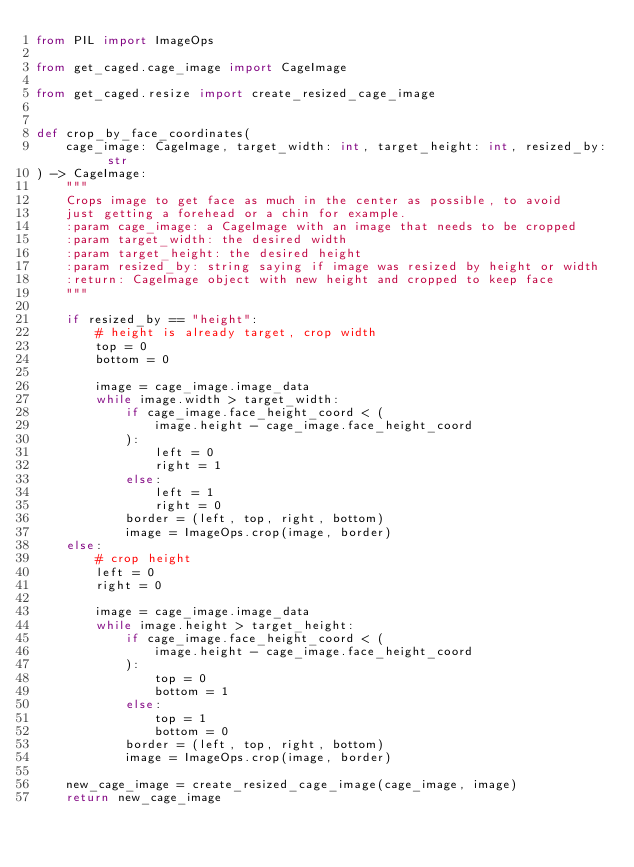<code> <loc_0><loc_0><loc_500><loc_500><_Python_>from PIL import ImageOps

from get_caged.cage_image import CageImage

from get_caged.resize import create_resized_cage_image


def crop_by_face_coordinates(
    cage_image: CageImage, target_width: int, target_height: int, resized_by: str
) -> CageImage:
    """
    Crops image to get face as much in the center as possible, to avoid
    just getting a forehead or a chin for example.
    :param cage_image: a CageImage with an image that needs to be cropped
    :param target_width: the desired width
    :param target_height: the desired height
    :param resized_by: string saying if image was resized by height or width
    :return: CageImage object with new height and cropped to keep face
    """

    if resized_by == "height":
        # height is already target, crop width
        top = 0
        bottom = 0

        image = cage_image.image_data
        while image.width > target_width:
            if cage_image.face_height_coord < (
                image.height - cage_image.face_height_coord
            ):
                left = 0
                right = 1
            else:
                left = 1
                right = 0
            border = (left, top, right, bottom)
            image = ImageOps.crop(image, border)
    else:
        # crop height
        left = 0
        right = 0

        image = cage_image.image_data
        while image.height > target_height:
            if cage_image.face_height_coord < (
                image.height - cage_image.face_height_coord
            ):
                top = 0
                bottom = 1
            else:
                top = 1
                bottom = 0
            border = (left, top, right, bottom)
            image = ImageOps.crop(image, border)

    new_cage_image = create_resized_cage_image(cage_image, image)
    return new_cage_image
</code> 